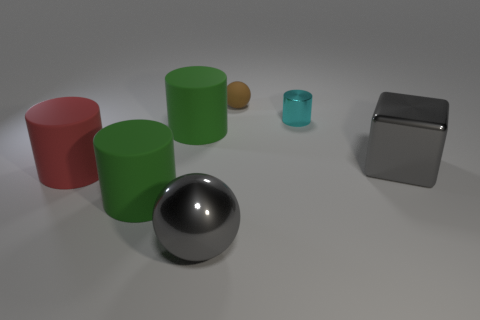Subtract all cyan metal cylinders. How many cylinders are left? 3 Subtract all purple balls. How many green cylinders are left? 2 Subtract all brown spheres. How many spheres are left? 1 Subtract 1 balls. How many balls are left? 1 Add 1 tiny cyan things. How many objects exist? 8 Subtract all spheres. How many objects are left? 5 Subtract all yellow cylinders. Subtract all brown blocks. How many cylinders are left? 4 Subtract all small purple objects. Subtract all large spheres. How many objects are left? 6 Add 5 small objects. How many small objects are left? 7 Add 2 red metal objects. How many red metal objects exist? 2 